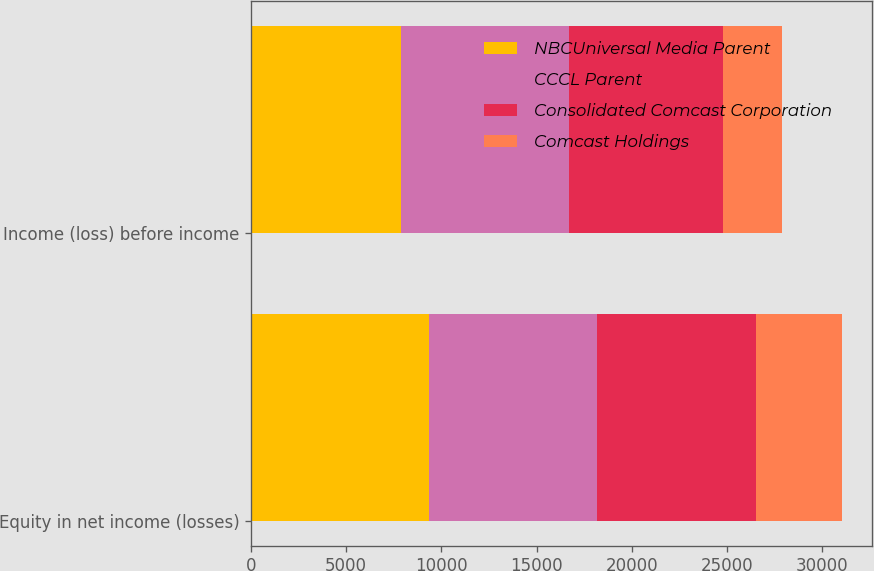Convert chart to OTSL. <chart><loc_0><loc_0><loc_500><loc_500><stacked_bar_chart><ecel><fcel>Equity in net income (losses)<fcel>Income (loss) before income<nl><fcel>NBCUniversal Media Parent<fcel>9330<fcel>7868<nl><fcel>CCCL Parent<fcel>8843<fcel>8844<nl><fcel>Consolidated Comcast Corporation<fcel>8350<fcel>8056<nl><fcel>Comcast Holdings<fcel>4523<fcel>3125<nl></chart> 